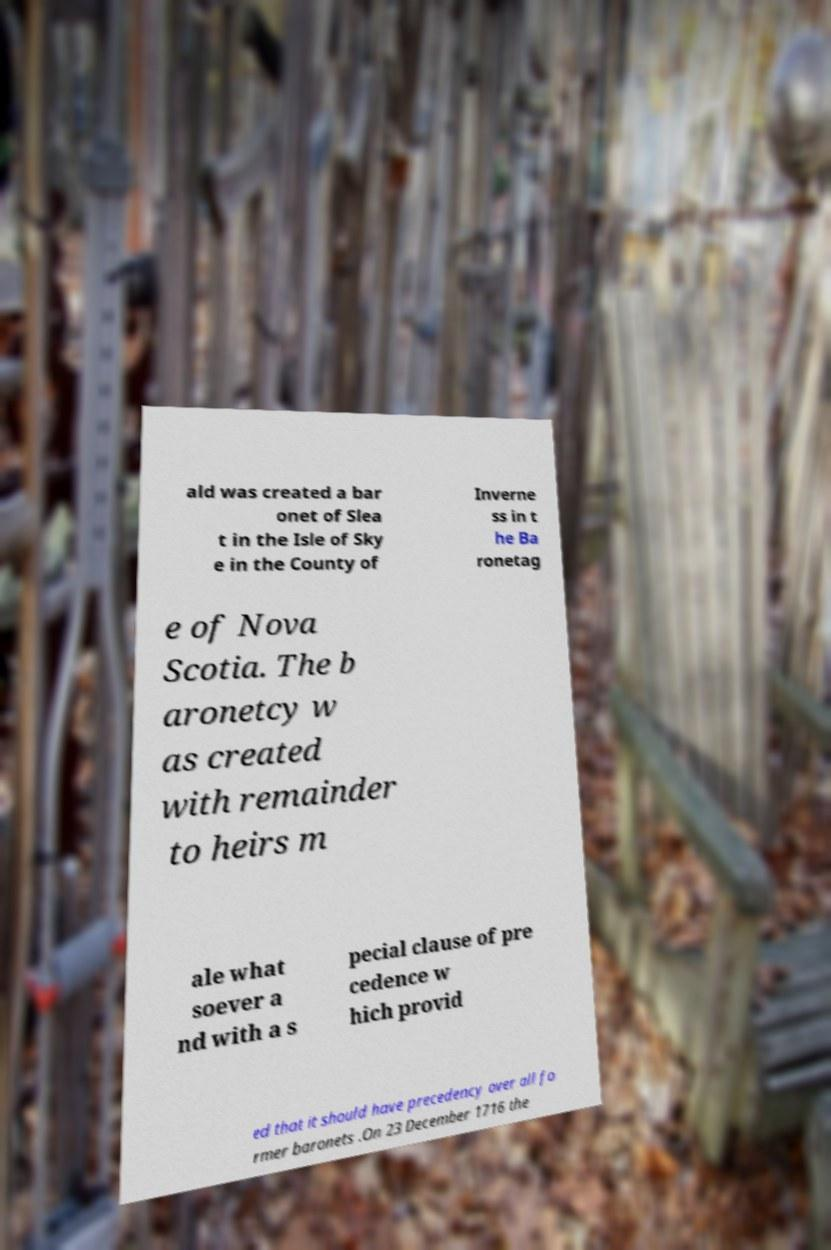Can you accurately transcribe the text from the provided image for me? ald was created a bar onet of Slea t in the Isle of Sky e in the County of Inverne ss in t he Ba ronetag e of Nova Scotia. The b aronetcy w as created with remainder to heirs m ale what soever a nd with a s pecial clause of pre cedence w hich provid ed that it should have precedency over all fo rmer baronets .On 23 December 1716 the 